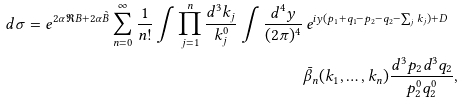<formula> <loc_0><loc_0><loc_500><loc_500>d \sigma = e ^ { 2 \alpha \Re B + 2 \alpha \tilde { B } } \sum _ { n = 0 } ^ { \infty } \frac { 1 } { n ! } \int \prod _ { j = 1 } ^ { n } \frac { d ^ { 3 } k _ { j } } { k _ { j } ^ { 0 } } \int \frac { d ^ { 4 } y } { ( 2 \pi ) ^ { 4 } } & \, e ^ { i y ( p _ { 1 } + q _ { 1 } - p _ { 2 } - q _ { 2 } - \sum _ { j } k _ { j } ) + D } \\ & \bar { \beta } _ { n } ( k _ { 1 } , \dots , k _ { n } ) \frac { d ^ { 3 } p _ { 2 } d ^ { 3 } q _ { 2 } } { p _ { 2 } ^ { 0 } q _ { 2 } ^ { 0 } } ,</formula> 